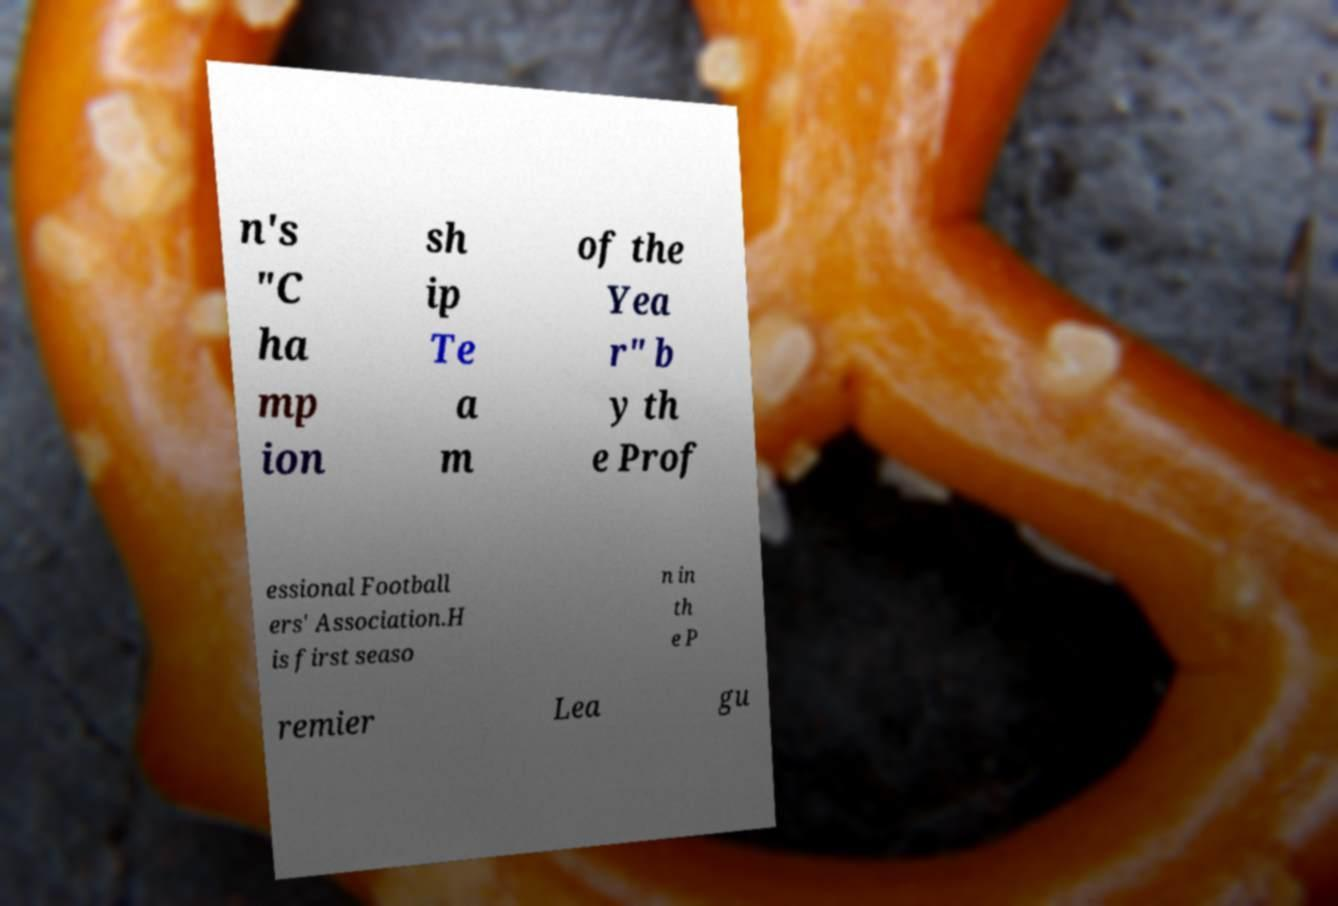Please identify and transcribe the text found in this image. n's "C ha mp ion sh ip Te a m of the Yea r" b y th e Prof essional Football ers' Association.H is first seaso n in th e P remier Lea gu 